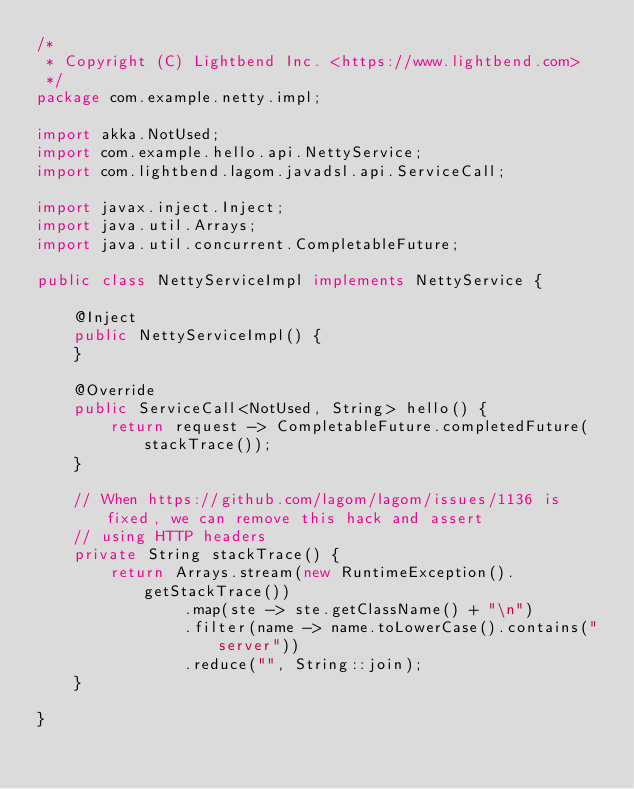Convert code to text. <code><loc_0><loc_0><loc_500><loc_500><_Java_>/*
 * Copyright (C) Lightbend Inc. <https://www.lightbend.com>
 */
package com.example.netty.impl;

import akka.NotUsed;
import com.example.hello.api.NettyService;
import com.lightbend.lagom.javadsl.api.ServiceCall;

import javax.inject.Inject;
import java.util.Arrays;
import java.util.concurrent.CompletableFuture;

public class NettyServiceImpl implements NettyService {

    @Inject
    public NettyServiceImpl() {
    }

    @Override
    public ServiceCall<NotUsed, String> hello() {
        return request -> CompletableFuture.completedFuture(stackTrace());
    }

    // When https://github.com/lagom/lagom/issues/1136 is fixed, we can remove this hack and assert
    // using HTTP headers
    private String stackTrace() {
        return Arrays.stream(new RuntimeException().getStackTrace())
                .map(ste -> ste.getClassName() + "\n")
                .filter(name -> name.toLowerCase().contains("server"))
                .reduce("", String::join);
    }

}
</code> 